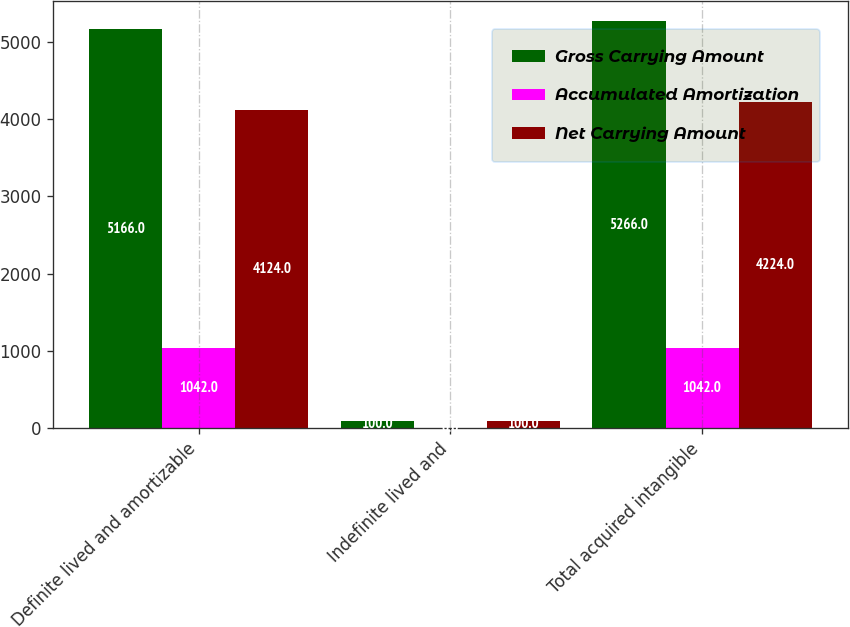Convert chart to OTSL. <chart><loc_0><loc_0><loc_500><loc_500><stacked_bar_chart><ecel><fcel>Definite lived and amortizable<fcel>Indefinite lived and<fcel>Total acquired intangible<nl><fcel>Gross Carrying Amount<fcel>5166<fcel>100<fcel>5266<nl><fcel>Accumulated Amortization<fcel>1042<fcel>0<fcel>1042<nl><fcel>Net Carrying Amount<fcel>4124<fcel>100<fcel>4224<nl></chart> 